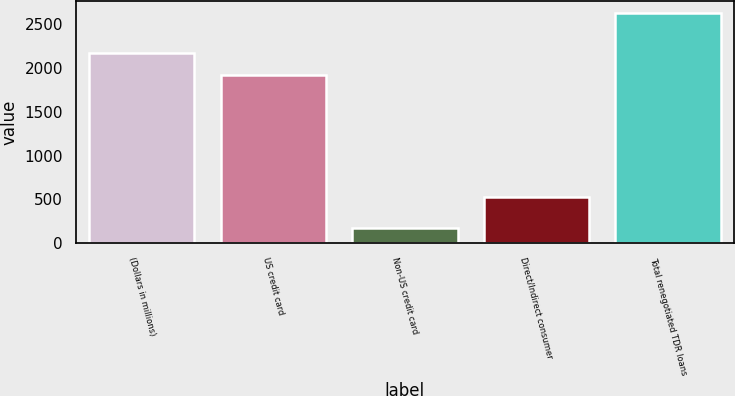Convert chart. <chart><loc_0><loc_0><loc_500><loc_500><bar_chart><fcel>(Dollars in millions)<fcel>US credit card<fcel>Non-US credit card<fcel>Direct/Indirect consumer<fcel>Total renegotiated TDR loans<nl><fcel>2172.8<fcel>1927<fcel>176<fcel>531<fcel>2634<nl></chart> 